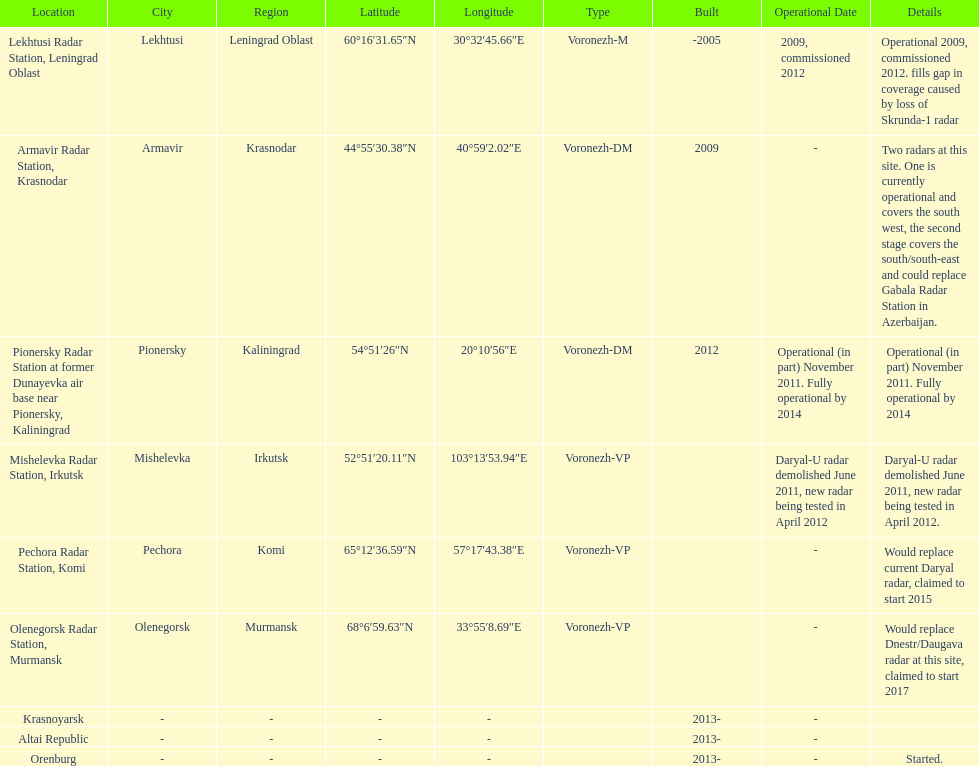Which voronezh radar has already started? Orenburg. Which radar would replace dnestr/daugava? Olenegorsk Radar Station, Murmansk. Which radar started in 2015? Pechora Radar Station, Komi. 